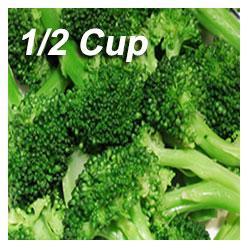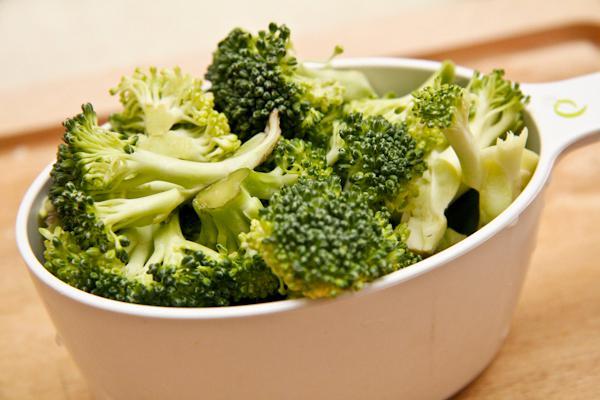The first image is the image on the left, the second image is the image on the right. For the images shown, is this caption "An image shows broccoli in a white container with a handle." true? Answer yes or no. Yes. The first image is the image on the left, the second image is the image on the right. For the images displayed, is the sentence "No dish is visible in the left image." factually correct? Answer yes or no. Yes. 